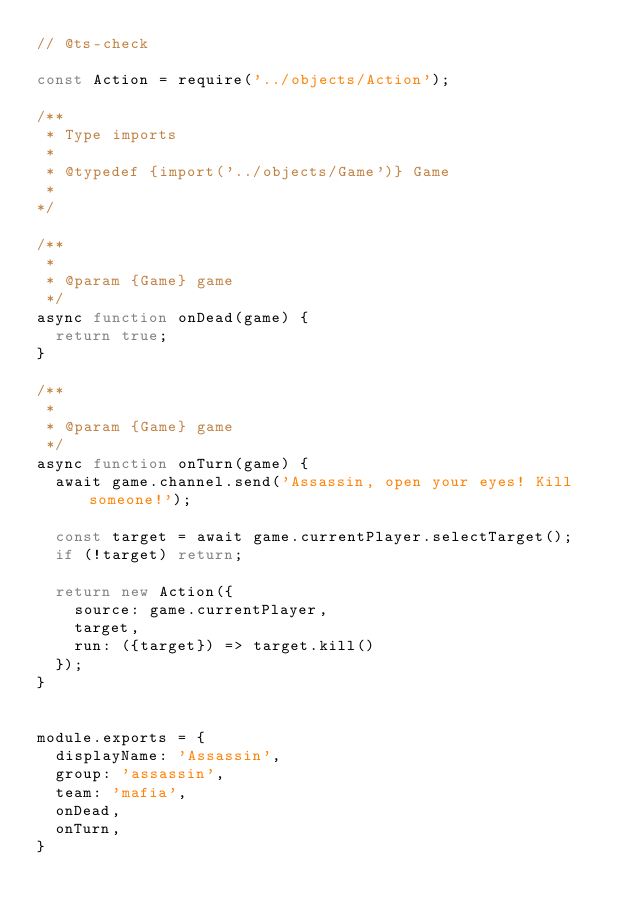<code> <loc_0><loc_0><loc_500><loc_500><_JavaScript_>// @ts-check

const Action = require('../objects/Action');

/**
 * Type imports
 *  
 * @typedef {import('../objects/Game')} Game
 * 
*/

/**
 * 
 * @param {Game} game
 */
async function onDead(game) {
  return true;
}

/**
 * 
 * @param {Game} game
 */
async function onTurn(game) {
  await game.channel.send('Assassin, open your eyes! Kill someone!');

  const target = await game.currentPlayer.selectTarget();
  if (!target) return;

  return new Action({
    source: game.currentPlayer,
    target,
    run: ({target}) => target.kill()
  });
}


module.exports = {
  displayName: 'Assassin',
  group: 'assassin',
  team: 'mafia',
  onDead,
  onTurn,
}</code> 